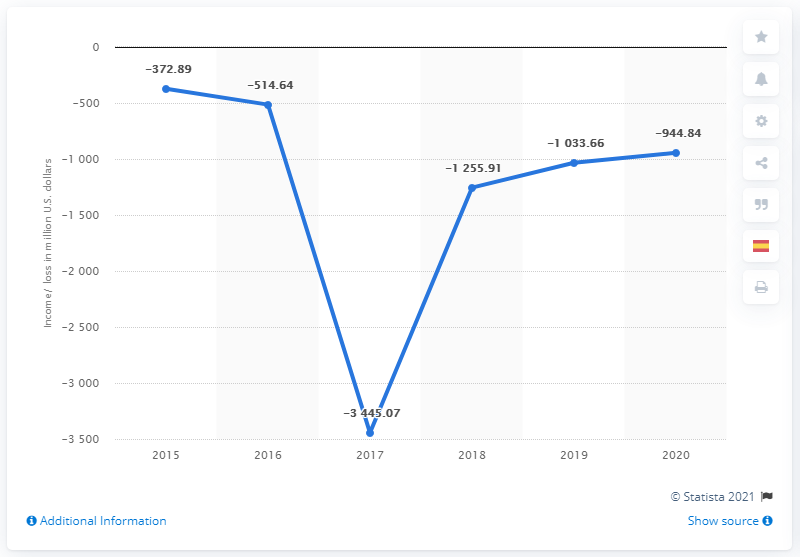Outline some significant characteristics in this image. In 2017, the global annual net loss significantly decreased. Our organization has suffered an annual net loss of approximately -3445.07 in the current global financial year. 